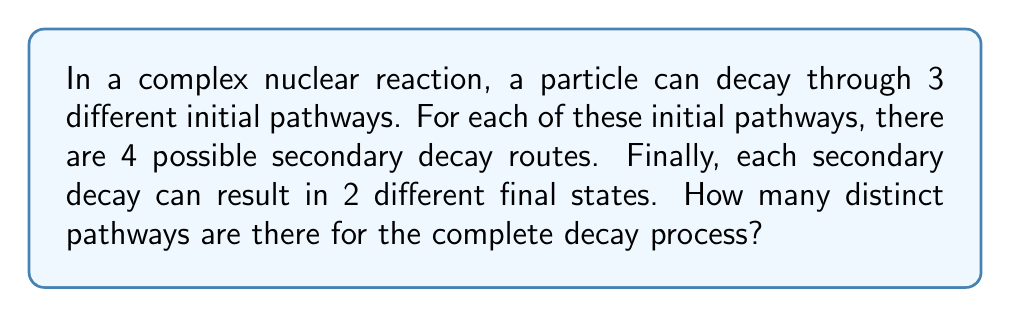What is the answer to this math problem? Let's approach this step-by-step:

1) We can visualize this decay process as a tree with three levels:
   - Level 1: Initial decay (3 options)
   - Level 2: Secondary decay (4 options for each initial decay)
   - Level 3: Final states (2 options for each secondary decay)

2) For each initial pathway:
   - There are 4 secondary decay routes
   - For each of these 4 routes, there are 2 final states

3) This means that for each initial pathway, there are $4 \times 2 = 8$ possible complete pathways

4) Since there are 3 initial pathways, and each of these has 8 complete pathways, the total number of distinct pathways is:

   $$ 3 \times (4 \times 2) = 3 \times 8 = 24 $$

5) We can also express this using the multiplication principle of counting:

   $$ 3 \times 4 \times 2 = 24 $$

   This represents the number of ways to choose an initial pathway, then a secondary decay route, and finally a final state.
Answer: 24 